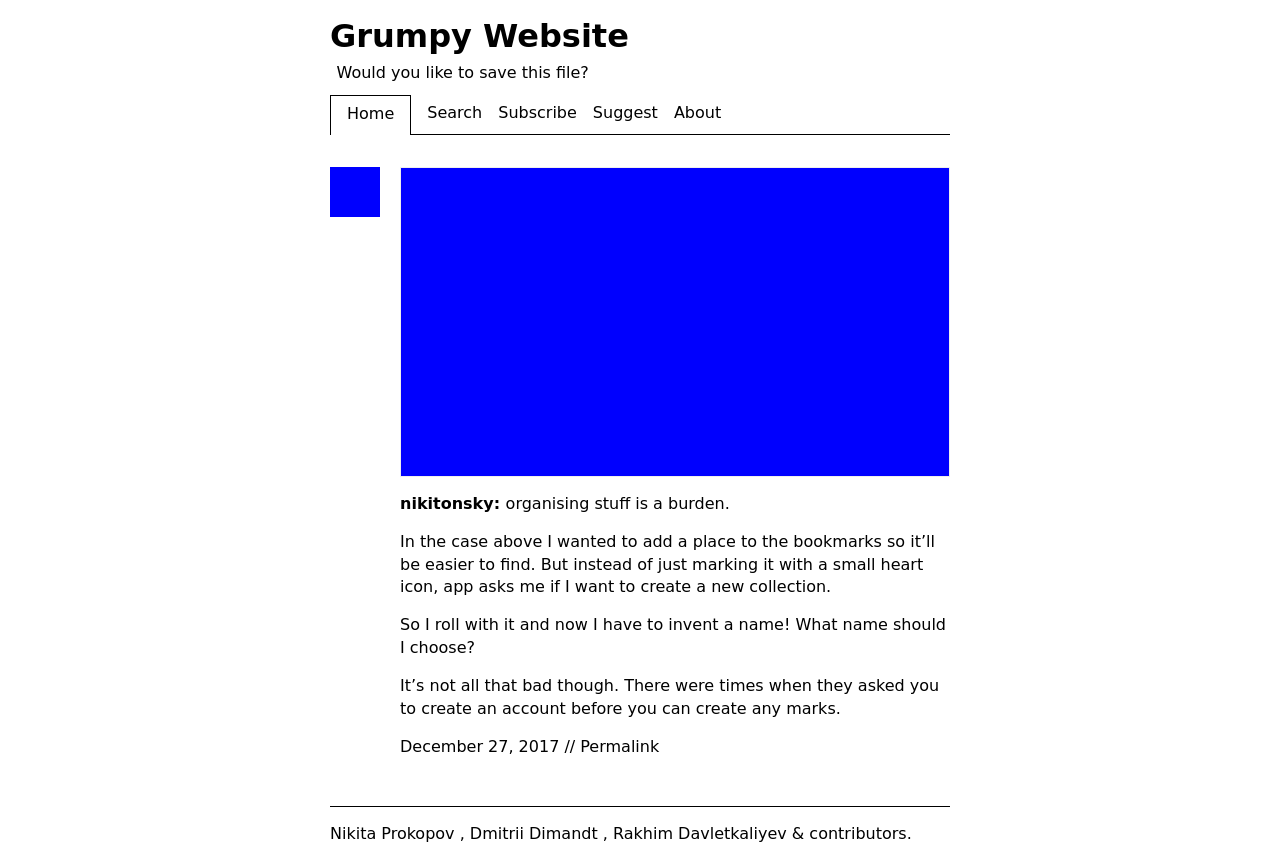Could you detail the process for assembling this website using HTML? The process for assembling a website like the one depicted in the image involves creating a structured HTML document that defines the content and layout, styling it with CSS, and potentially adding interactivity with JavaScript. The HTML serves as the skeleton, containing elements such as headers, paragraphs, and divs. CSS is used to style these elements, positioning them on the page, coloring them, setting fonts, etc. Modern websites also include responsive design features, adjusting the layout according to the device used to view the site. Lastly, JavaScript can add interactive components like slideshows or form validation. 